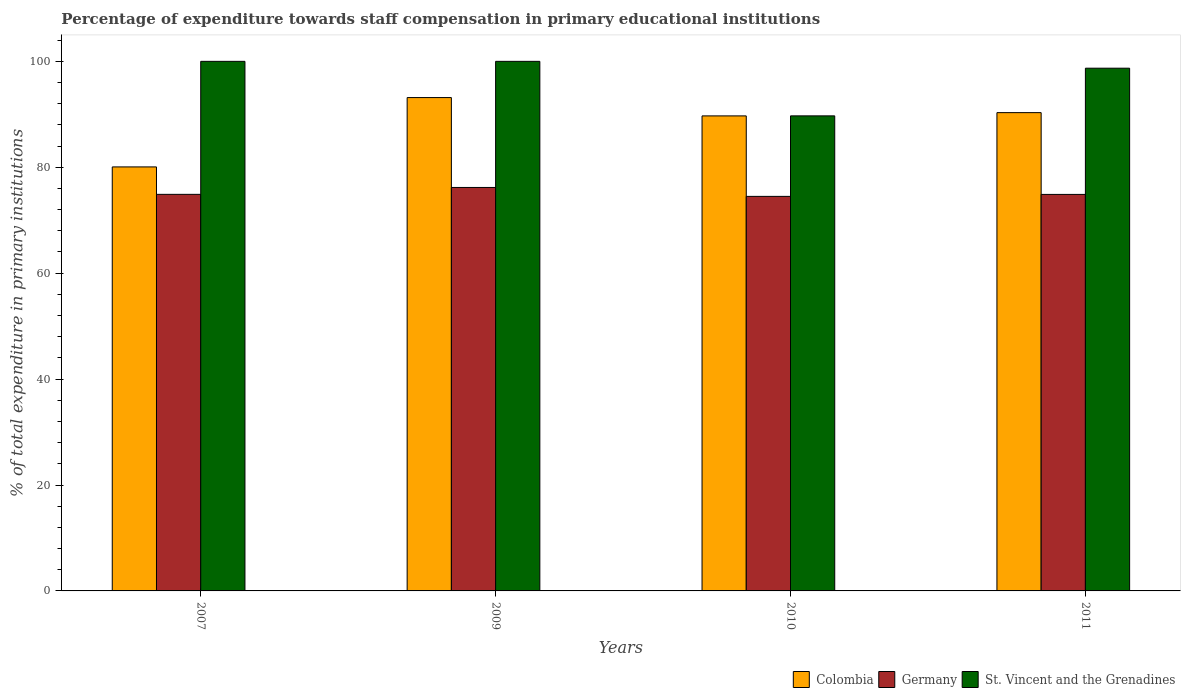In how many cases, is the number of bars for a given year not equal to the number of legend labels?
Offer a very short reply. 0. What is the percentage of expenditure towards staff compensation in St. Vincent and the Grenadines in 2010?
Your response must be concise. 89.71. Across all years, what is the maximum percentage of expenditure towards staff compensation in Colombia?
Offer a terse response. 93.16. Across all years, what is the minimum percentage of expenditure towards staff compensation in St. Vincent and the Grenadines?
Make the answer very short. 89.71. In which year was the percentage of expenditure towards staff compensation in St. Vincent and the Grenadines minimum?
Give a very brief answer. 2010. What is the total percentage of expenditure towards staff compensation in Colombia in the graph?
Provide a short and direct response. 353.24. What is the difference between the percentage of expenditure towards staff compensation in Germany in 2009 and that in 2011?
Your response must be concise. 1.32. What is the difference between the percentage of expenditure towards staff compensation in Colombia in 2007 and the percentage of expenditure towards staff compensation in St. Vincent and the Grenadines in 2011?
Provide a succinct answer. -18.64. What is the average percentage of expenditure towards staff compensation in Germany per year?
Keep it short and to the point. 75.11. In the year 2010, what is the difference between the percentage of expenditure towards staff compensation in St. Vincent and the Grenadines and percentage of expenditure towards staff compensation in Germany?
Offer a very short reply. 15.21. In how many years, is the percentage of expenditure towards staff compensation in St. Vincent and the Grenadines greater than 88 %?
Offer a terse response. 4. What is the ratio of the percentage of expenditure towards staff compensation in St. Vincent and the Grenadines in 2007 to that in 2011?
Make the answer very short. 1.01. Is the percentage of expenditure towards staff compensation in St. Vincent and the Grenadines in 2010 less than that in 2011?
Your answer should be very brief. Yes. Is the difference between the percentage of expenditure towards staff compensation in St. Vincent and the Grenadines in 2007 and 2010 greater than the difference between the percentage of expenditure towards staff compensation in Germany in 2007 and 2010?
Your response must be concise. Yes. What is the difference between the highest and the second highest percentage of expenditure towards staff compensation in Germany?
Your answer should be very brief. 1.3. What is the difference between the highest and the lowest percentage of expenditure towards staff compensation in Germany?
Offer a very short reply. 1.69. In how many years, is the percentage of expenditure towards staff compensation in Colombia greater than the average percentage of expenditure towards staff compensation in Colombia taken over all years?
Provide a short and direct response. 3. What does the 1st bar from the right in 2010 represents?
Give a very brief answer. St. Vincent and the Grenadines. How many years are there in the graph?
Give a very brief answer. 4. Are the values on the major ticks of Y-axis written in scientific E-notation?
Your answer should be compact. No. Does the graph contain grids?
Give a very brief answer. No. How are the legend labels stacked?
Offer a terse response. Horizontal. What is the title of the graph?
Provide a succinct answer. Percentage of expenditure towards staff compensation in primary educational institutions. What is the label or title of the Y-axis?
Give a very brief answer. % of total expenditure in primary institutions. What is the % of total expenditure in primary institutions in Colombia in 2007?
Provide a succinct answer. 80.07. What is the % of total expenditure in primary institutions of Germany in 2007?
Ensure brevity in your answer.  74.88. What is the % of total expenditure in primary institutions in Colombia in 2009?
Ensure brevity in your answer.  93.16. What is the % of total expenditure in primary institutions of Germany in 2009?
Make the answer very short. 76.19. What is the % of total expenditure in primary institutions of St. Vincent and the Grenadines in 2009?
Provide a short and direct response. 100. What is the % of total expenditure in primary institutions of Colombia in 2010?
Your answer should be compact. 89.7. What is the % of total expenditure in primary institutions in Germany in 2010?
Keep it short and to the point. 74.5. What is the % of total expenditure in primary institutions in St. Vincent and the Grenadines in 2010?
Offer a very short reply. 89.71. What is the % of total expenditure in primary institutions in Colombia in 2011?
Provide a succinct answer. 90.32. What is the % of total expenditure in primary institutions of Germany in 2011?
Provide a short and direct response. 74.87. What is the % of total expenditure in primary institutions of St. Vincent and the Grenadines in 2011?
Keep it short and to the point. 98.71. Across all years, what is the maximum % of total expenditure in primary institutions of Colombia?
Make the answer very short. 93.16. Across all years, what is the maximum % of total expenditure in primary institutions of Germany?
Keep it short and to the point. 76.19. Across all years, what is the minimum % of total expenditure in primary institutions of Colombia?
Make the answer very short. 80.07. Across all years, what is the minimum % of total expenditure in primary institutions of Germany?
Make the answer very short. 74.5. Across all years, what is the minimum % of total expenditure in primary institutions of St. Vincent and the Grenadines?
Offer a very short reply. 89.71. What is the total % of total expenditure in primary institutions of Colombia in the graph?
Provide a succinct answer. 353.24. What is the total % of total expenditure in primary institutions in Germany in the graph?
Your response must be concise. 300.45. What is the total % of total expenditure in primary institutions of St. Vincent and the Grenadines in the graph?
Offer a terse response. 388.42. What is the difference between the % of total expenditure in primary institutions in Colombia in 2007 and that in 2009?
Ensure brevity in your answer.  -13.09. What is the difference between the % of total expenditure in primary institutions of Germany in 2007 and that in 2009?
Provide a succinct answer. -1.3. What is the difference between the % of total expenditure in primary institutions of Colombia in 2007 and that in 2010?
Ensure brevity in your answer.  -9.64. What is the difference between the % of total expenditure in primary institutions of Germany in 2007 and that in 2010?
Provide a short and direct response. 0.38. What is the difference between the % of total expenditure in primary institutions in St. Vincent and the Grenadines in 2007 and that in 2010?
Provide a short and direct response. 10.29. What is the difference between the % of total expenditure in primary institutions of Colombia in 2007 and that in 2011?
Make the answer very short. -10.25. What is the difference between the % of total expenditure in primary institutions of Germany in 2007 and that in 2011?
Your answer should be compact. 0.01. What is the difference between the % of total expenditure in primary institutions of St. Vincent and the Grenadines in 2007 and that in 2011?
Give a very brief answer. 1.29. What is the difference between the % of total expenditure in primary institutions of Colombia in 2009 and that in 2010?
Provide a succinct answer. 3.46. What is the difference between the % of total expenditure in primary institutions of Germany in 2009 and that in 2010?
Provide a short and direct response. 1.69. What is the difference between the % of total expenditure in primary institutions of St. Vincent and the Grenadines in 2009 and that in 2010?
Your answer should be very brief. 10.29. What is the difference between the % of total expenditure in primary institutions in Colombia in 2009 and that in 2011?
Make the answer very short. 2.84. What is the difference between the % of total expenditure in primary institutions of Germany in 2009 and that in 2011?
Ensure brevity in your answer.  1.32. What is the difference between the % of total expenditure in primary institutions of St. Vincent and the Grenadines in 2009 and that in 2011?
Give a very brief answer. 1.29. What is the difference between the % of total expenditure in primary institutions of Colombia in 2010 and that in 2011?
Provide a short and direct response. -0.62. What is the difference between the % of total expenditure in primary institutions of Germany in 2010 and that in 2011?
Make the answer very short. -0.37. What is the difference between the % of total expenditure in primary institutions of St. Vincent and the Grenadines in 2010 and that in 2011?
Make the answer very short. -9. What is the difference between the % of total expenditure in primary institutions of Colombia in 2007 and the % of total expenditure in primary institutions of Germany in 2009?
Give a very brief answer. 3.88. What is the difference between the % of total expenditure in primary institutions of Colombia in 2007 and the % of total expenditure in primary institutions of St. Vincent and the Grenadines in 2009?
Provide a succinct answer. -19.93. What is the difference between the % of total expenditure in primary institutions of Germany in 2007 and the % of total expenditure in primary institutions of St. Vincent and the Grenadines in 2009?
Your answer should be very brief. -25.12. What is the difference between the % of total expenditure in primary institutions in Colombia in 2007 and the % of total expenditure in primary institutions in Germany in 2010?
Provide a short and direct response. 5.56. What is the difference between the % of total expenditure in primary institutions in Colombia in 2007 and the % of total expenditure in primary institutions in St. Vincent and the Grenadines in 2010?
Provide a succinct answer. -9.64. What is the difference between the % of total expenditure in primary institutions in Germany in 2007 and the % of total expenditure in primary institutions in St. Vincent and the Grenadines in 2010?
Your answer should be compact. -14.82. What is the difference between the % of total expenditure in primary institutions of Colombia in 2007 and the % of total expenditure in primary institutions of Germany in 2011?
Ensure brevity in your answer.  5.19. What is the difference between the % of total expenditure in primary institutions of Colombia in 2007 and the % of total expenditure in primary institutions of St. Vincent and the Grenadines in 2011?
Your response must be concise. -18.64. What is the difference between the % of total expenditure in primary institutions in Germany in 2007 and the % of total expenditure in primary institutions in St. Vincent and the Grenadines in 2011?
Your answer should be very brief. -23.82. What is the difference between the % of total expenditure in primary institutions in Colombia in 2009 and the % of total expenditure in primary institutions in Germany in 2010?
Your answer should be compact. 18.66. What is the difference between the % of total expenditure in primary institutions of Colombia in 2009 and the % of total expenditure in primary institutions of St. Vincent and the Grenadines in 2010?
Make the answer very short. 3.45. What is the difference between the % of total expenditure in primary institutions in Germany in 2009 and the % of total expenditure in primary institutions in St. Vincent and the Grenadines in 2010?
Keep it short and to the point. -13.52. What is the difference between the % of total expenditure in primary institutions in Colombia in 2009 and the % of total expenditure in primary institutions in Germany in 2011?
Offer a terse response. 18.29. What is the difference between the % of total expenditure in primary institutions of Colombia in 2009 and the % of total expenditure in primary institutions of St. Vincent and the Grenadines in 2011?
Your answer should be very brief. -5.55. What is the difference between the % of total expenditure in primary institutions in Germany in 2009 and the % of total expenditure in primary institutions in St. Vincent and the Grenadines in 2011?
Your response must be concise. -22.52. What is the difference between the % of total expenditure in primary institutions in Colombia in 2010 and the % of total expenditure in primary institutions in Germany in 2011?
Your answer should be very brief. 14.83. What is the difference between the % of total expenditure in primary institutions in Colombia in 2010 and the % of total expenditure in primary institutions in St. Vincent and the Grenadines in 2011?
Provide a short and direct response. -9.01. What is the difference between the % of total expenditure in primary institutions in Germany in 2010 and the % of total expenditure in primary institutions in St. Vincent and the Grenadines in 2011?
Provide a short and direct response. -24.21. What is the average % of total expenditure in primary institutions in Colombia per year?
Ensure brevity in your answer.  88.31. What is the average % of total expenditure in primary institutions of Germany per year?
Ensure brevity in your answer.  75.11. What is the average % of total expenditure in primary institutions of St. Vincent and the Grenadines per year?
Offer a terse response. 97.1. In the year 2007, what is the difference between the % of total expenditure in primary institutions of Colombia and % of total expenditure in primary institutions of Germany?
Keep it short and to the point. 5.18. In the year 2007, what is the difference between the % of total expenditure in primary institutions of Colombia and % of total expenditure in primary institutions of St. Vincent and the Grenadines?
Ensure brevity in your answer.  -19.93. In the year 2007, what is the difference between the % of total expenditure in primary institutions in Germany and % of total expenditure in primary institutions in St. Vincent and the Grenadines?
Provide a short and direct response. -25.12. In the year 2009, what is the difference between the % of total expenditure in primary institutions of Colombia and % of total expenditure in primary institutions of Germany?
Your answer should be very brief. 16.97. In the year 2009, what is the difference between the % of total expenditure in primary institutions of Colombia and % of total expenditure in primary institutions of St. Vincent and the Grenadines?
Provide a succinct answer. -6.84. In the year 2009, what is the difference between the % of total expenditure in primary institutions of Germany and % of total expenditure in primary institutions of St. Vincent and the Grenadines?
Provide a short and direct response. -23.81. In the year 2010, what is the difference between the % of total expenditure in primary institutions in Colombia and % of total expenditure in primary institutions in Germany?
Offer a terse response. 15.2. In the year 2010, what is the difference between the % of total expenditure in primary institutions in Colombia and % of total expenditure in primary institutions in St. Vincent and the Grenadines?
Give a very brief answer. -0.01. In the year 2010, what is the difference between the % of total expenditure in primary institutions in Germany and % of total expenditure in primary institutions in St. Vincent and the Grenadines?
Ensure brevity in your answer.  -15.21. In the year 2011, what is the difference between the % of total expenditure in primary institutions of Colombia and % of total expenditure in primary institutions of Germany?
Offer a terse response. 15.44. In the year 2011, what is the difference between the % of total expenditure in primary institutions of Colombia and % of total expenditure in primary institutions of St. Vincent and the Grenadines?
Your answer should be compact. -8.39. In the year 2011, what is the difference between the % of total expenditure in primary institutions of Germany and % of total expenditure in primary institutions of St. Vincent and the Grenadines?
Your answer should be very brief. -23.84. What is the ratio of the % of total expenditure in primary institutions of Colombia in 2007 to that in 2009?
Keep it short and to the point. 0.86. What is the ratio of the % of total expenditure in primary institutions of Germany in 2007 to that in 2009?
Make the answer very short. 0.98. What is the ratio of the % of total expenditure in primary institutions in St. Vincent and the Grenadines in 2007 to that in 2009?
Your response must be concise. 1. What is the ratio of the % of total expenditure in primary institutions of Colombia in 2007 to that in 2010?
Ensure brevity in your answer.  0.89. What is the ratio of the % of total expenditure in primary institutions of St. Vincent and the Grenadines in 2007 to that in 2010?
Your answer should be very brief. 1.11. What is the ratio of the % of total expenditure in primary institutions of Colombia in 2007 to that in 2011?
Your answer should be compact. 0.89. What is the ratio of the % of total expenditure in primary institutions of St. Vincent and the Grenadines in 2007 to that in 2011?
Provide a succinct answer. 1.01. What is the ratio of the % of total expenditure in primary institutions in Colombia in 2009 to that in 2010?
Ensure brevity in your answer.  1.04. What is the ratio of the % of total expenditure in primary institutions in Germany in 2009 to that in 2010?
Give a very brief answer. 1.02. What is the ratio of the % of total expenditure in primary institutions in St. Vincent and the Grenadines in 2009 to that in 2010?
Make the answer very short. 1.11. What is the ratio of the % of total expenditure in primary institutions in Colombia in 2009 to that in 2011?
Make the answer very short. 1.03. What is the ratio of the % of total expenditure in primary institutions of Germany in 2009 to that in 2011?
Your answer should be compact. 1.02. What is the ratio of the % of total expenditure in primary institutions in St. Vincent and the Grenadines in 2009 to that in 2011?
Your answer should be compact. 1.01. What is the ratio of the % of total expenditure in primary institutions in Colombia in 2010 to that in 2011?
Make the answer very short. 0.99. What is the ratio of the % of total expenditure in primary institutions of Germany in 2010 to that in 2011?
Your response must be concise. 0.99. What is the ratio of the % of total expenditure in primary institutions in St. Vincent and the Grenadines in 2010 to that in 2011?
Make the answer very short. 0.91. What is the difference between the highest and the second highest % of total expenditure in primary institutions in Colombia?
Your answer should be very brief. 2.84. What is the difference between the highest and the second highest % of total expenditure in primary institutions in Germany?
Give a very brief answer. 1.3. What is the difference between the highest and the second highest % of total expenditure in primary institutions of St. Vincent and the Grenadines?
Provide a succinct answer. 0. What is the difference between the highest and the lowest % of total expenditure in primary institutions in Colombia?
Make the answer very short. 13.09. What is the difference between the highest and the lowest % of total expenditure in primary institutions in Germany?
Keep it short and to the point. 1.69. What is the difference between the highest and the lowest % of total expenditure in primary institutions of St. Vincent and the Grenadines?
Your answer should be very brief. 10.29. 